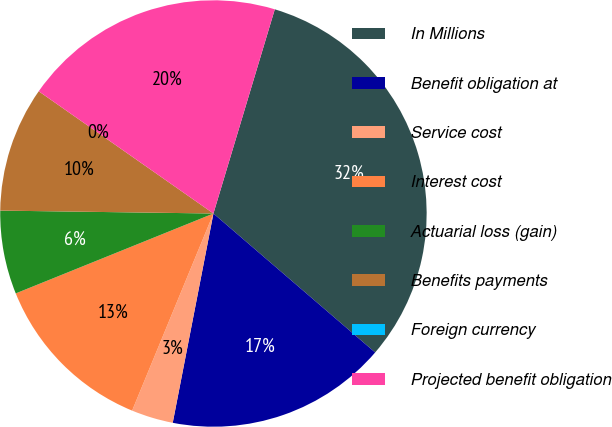<chart> <loc_0><loc_0><loc_500><loc_500><pie_chart><fcel>In Millions<fcel>Benefit obligation at<fcel>Service cost<fcel>Interest cost<fcel>Actuarial loss (gain)<fcel>Benefits payments<fcel>Foreign currency<fcel>Projected benefit obligation<nl><fcel>31.65%<fcel>16.76%<fcel>3.17%<fcel>12.66%<fcel>6.33%<fcel>9.5%<fcel>0.0%<fcel>19.93%<nl></chart> 